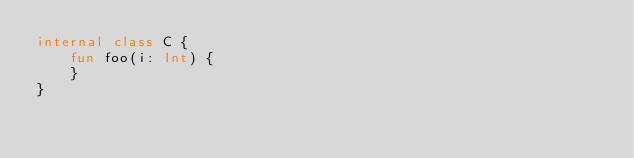<code> <loc_0><loc_0><loc_500><loc_500><_Kotlin_>internal class C {
    fun foo(i: Int) {
    }
}
</code> 